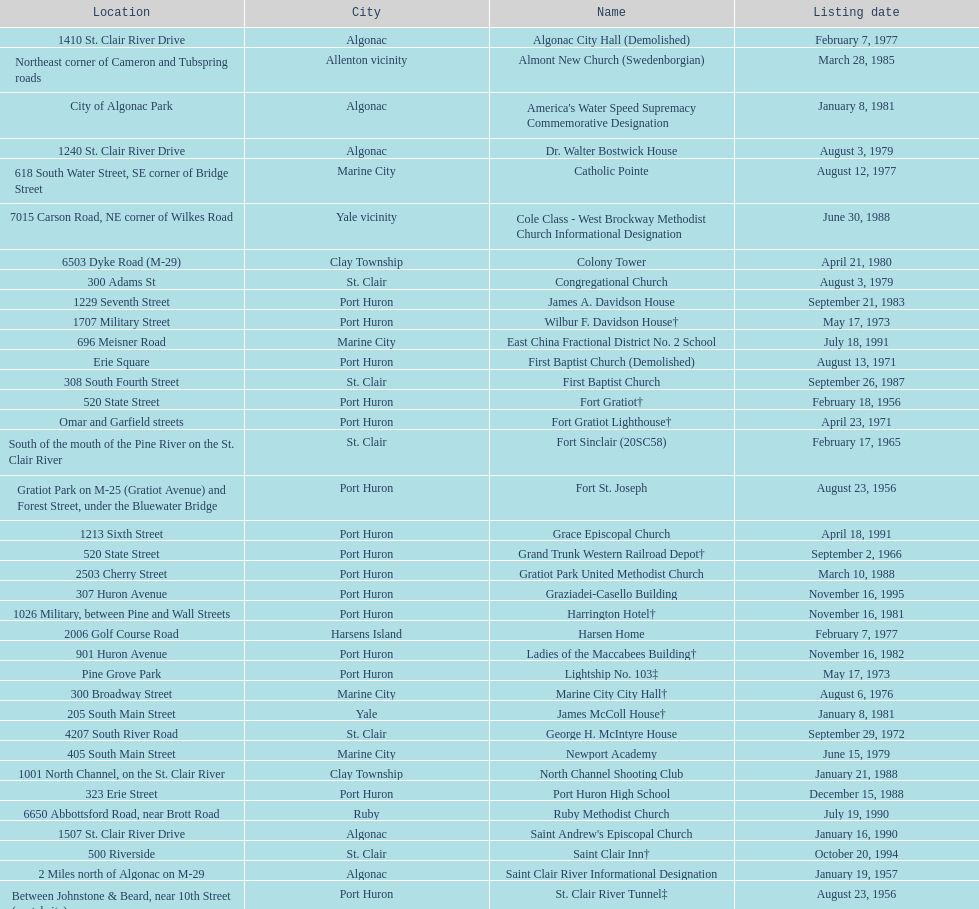Parse the table in full. {'header': ['Location', 'City', 'Name', 'Listing date'], 'rows': [['1410 St. Clair River Drive', 'Algonac', 'Algonac City Hall (Demolished)', 'February 7, 1977'], ['Northeast corner of Cameron and Tubspring roads', 'Allenton vicinity', 'Almont New Church (Swedenborgian)', 'March 28, 1985'], ['City of Algonac Park', 'Algonac', "America's Water Speed Supremacy Commemorative Designation", 'January 8, 1981'], ['1240 St. Clair River Drive', 'Algonac', 'Dr. Walter Bostwick House', 'August 3, 1979'], ['618 South Water Street, SE corner of Bridge Street', 'Marine City', 'Catholic Pointe', 'August 12, 1977'], ['7015 Carson Road, NE corner of Wilkes Road', 'Yale vicinity', 'Cole Class - West Brockway Methodist Church Informational Designation', 'June 30, 1988'], ['6503 Dyke Road (M-29)', 'Clay Township', 'Colony Tower', 'April 21, 1980'], ['300 Adams St', 'St. Clair', 'Congregational Church', 'August 3, 1979'], ['1229 Seventh Street', 'Port Huron', 'James A. Davidson House', 'September 21, 1983'], ['1707 Military Street', 'Port Huron', 'Wilbur F. Davidson House†', 'May 17, 1973'], ['696 Meisner Road', 'Marine City', 'East China Fractional District No. 2 School', 'July 18, 1991'], ['Erie Square', 'Port Huron', 'First Baptist Church (Demolished)', 'August 13, 1971'], ['308 South Fourth Street', 'St. Clair', 'First Baptist Church', 'September 26, 1987'], ['520 State Street', 'Port Huron', 'Fort Gratiot†', 'February 18, 1956'], ['Omar and Garfield streets', 'Port Huron', 'Fort Gratiot Lighthouse†', 'April 23, 1971'], ['South of the mouth of the Pine River on the St. Clair River', 'St. Clair', 'Fort Sinclair (20SC58)', 'February 17, 1965'], ['Gratiot Park on M-25 (Gratiot Avenue) and Forest Street, under the Bluewater Bridge', 'Port Huron', 'Fort St. Joseph', 'August 23, 1956'], ['1213 Sixth Street', 'Port Huron', 'Grace Episcopal Church', 'April 18, 1991'], ['520 State Street', 'Port Huron', 'Grand Trunk Western Railroad Depot†', 'September 2, 1966'], ['2503 Cherry Street', 'Port Huron', 'Gratiot Park United Methodist Church', 'March 10, 1988'], ['307 Huron Avenue', 'Port Huron', 'Graziadei-Casello Building', 'November 16, 1995'], ['1026 Military, between Pine and Wall Streets', 'Port Huron', 'Harrington Hotel†', 'November 16, 1981'], ['2006 Golf Course Road', 'Harsens Island', 'Harsen Home', 'February 7, 1977'], ['901 Huron Avenue', 'Port Huron', 'Ladies of the Maccabees Building†', 'November 16, 1982'], ['Pine Grove Park', 'Port Huron', 'Lightship No. 103‡', 'May 17, 1973'], ['300 Broadway Street', 'Marine City', 'Marine City City Hall†', 'August 6, 1976'], ['205 South Main Street', 'Yale', 'James McColl House†', 'January 8, 1981'], ['4207 South River Road', 'St. Clair', 'George H. McIntyre House', 'September 29, 1972'], ['405 South Main Street', 'Marine City', 'Newport Academy', 'June 15, 1979'], ['1001 North Channel, on the St. Clair River', 'Clay Township', 'North Channel Shooting Club', 'January 21, 1988'], ['323 Erie Street', 'Port Huron', 'Port Huron High School', 'December 15, 1988'], ['6650 Abbottsford Road, near Brott Road', 'Ruby', 'Ruby Methodist Church', 'July 19, 1990'], ['1507 St. Clair River Drive', 'Algonac', "Saint Andrew's Episcopal Church", 'January 16, 1990'], ['500 Riverside', 'St. Clair', 'Saint Clair Inn†', 'October 20, 1994'], ['2 Miles north of Algonac on M-29', 'Algonac', 'Saint Clair River Informational Designation', 'January 19, 1957'], ['Between Johnstone & Beard, near 10th Street (portal site)', 'Port Huron', 'St. Clair River Tunnel‡', 'August 23, 1956'], ['710 Pine Street, at Seventh Street', 'Port Huron', 'Saint Johannes Evangelische Kirche', 'March 19, 1980'], ['415 North Sixth Street, between Vine and Orchard streets', 'St. Clair', "Saint Mary's Catholic Church and Rectory", 'September 25, 1985'], ['807 Prospect Place', 'Port Huron', 'Jefferson Sheldon House', 'April 19, 1990'], ['1517 Tenth Street', 'Port Huron', 'Trinity Evangelical Lutheran Church', 'August 29, 1996'], ['1372 Wales Center', 'Wales Township', 'Wales Township Hall', 'July 18, 1996'], ['433 North Main Street', 'Marine City', 'Ward-Holland House†', 'May 5, 1964'], ['2511 Tenth Avenue, between Hancock and Church streets', 'Port Huron', 'E. C. Williams House', 'November 18, 1993'], ['Chrysler Plant, 840 Huron Avenue', 'Marysville', 'C. H. Wills & Company', 'June 23, 1983'], ['1338 Military Street', 'Port Huron', "Woman's Benefit Association Building", 'December 15, 1988']]} How many names do not have images next to them? 41. 